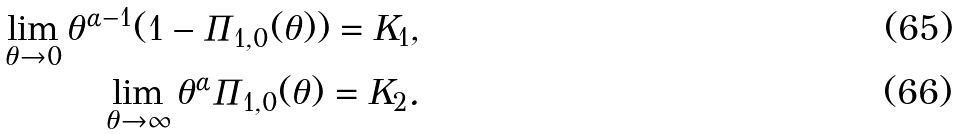<formula> <loc_0><loc_0><loc_500><loc_500>\lim _ { \theta \to 0 } \theta ^ { \alpha - 1 } ( 1 - \Pi _ { 1 , 0 } ( \theta ) ) = K _ { 1 } , \\ \lim _ { \theta \to \infty } \theta ^ { \alpha } \Pi _ { 1 , 0 } ( \theta ) = K _ { 2 } .</formula> 